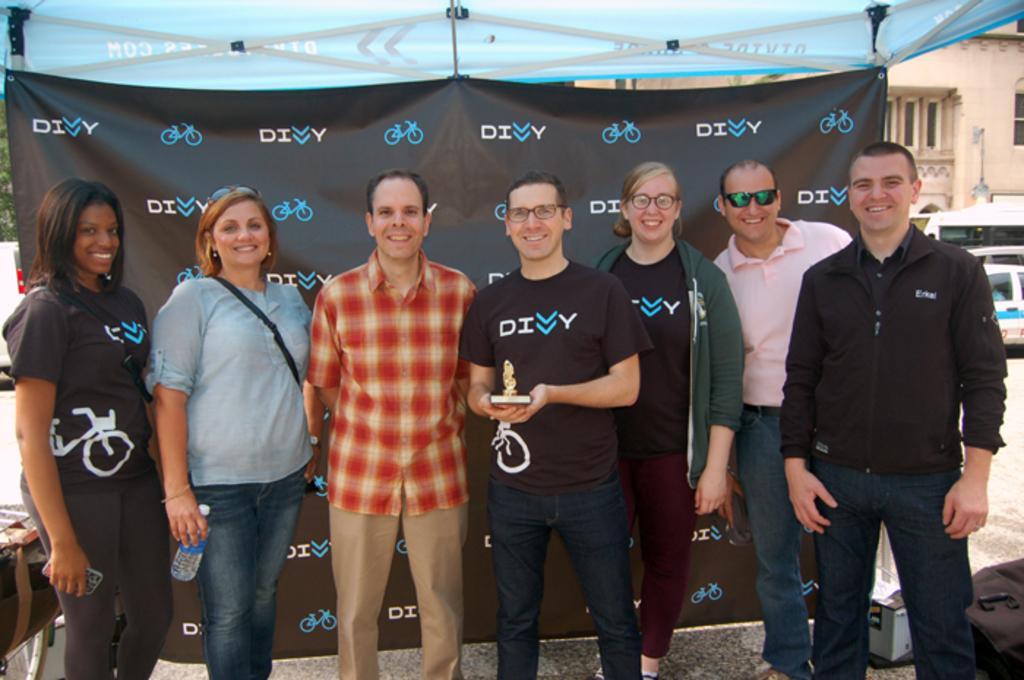How would you summarize this image in a sentence or two? In the center of the image we can see people standing. The man standing in the center is holding a statue. In the background there is a tent, building and we can see vehicles. At the bottom there is a road. 